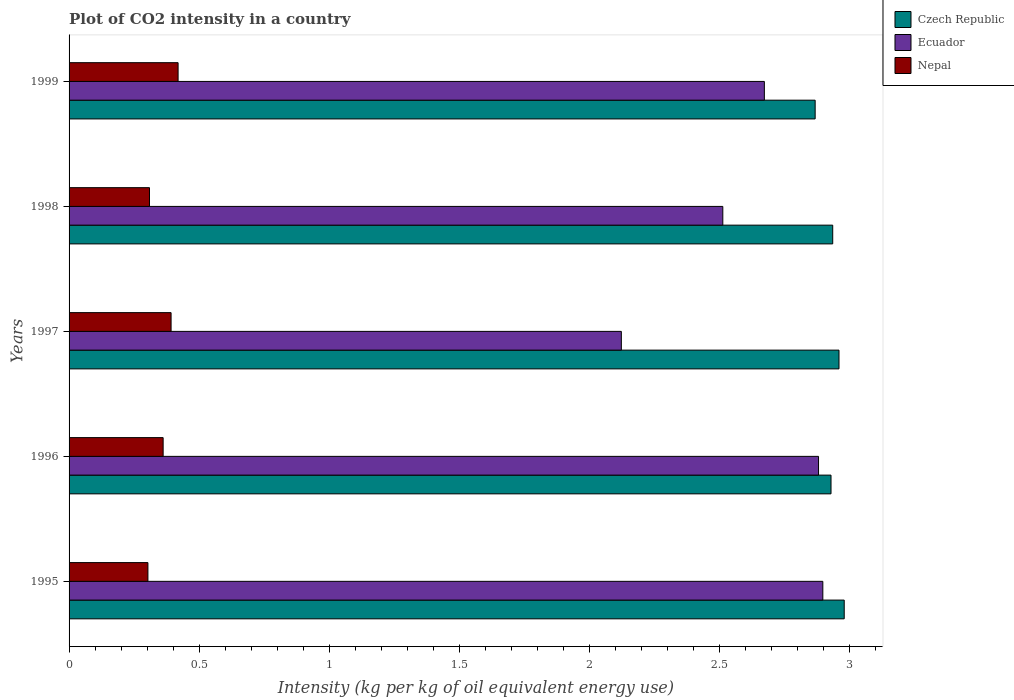Are the number of bars per tick equal to the number of legend labels?
Make the answer very short. Yes. Are the number of bars on each tick of the Y-axis equal?
Your response must be concise. Yes. How many bars are there on the 2nd tick from the top?
Give a very brief answer. 3. How many bars are there on the 2nd tick from the bottom?
Your answer should be compact. 3. In how many cases, is the number of bars for a given year not equal to the number of legend labels?
Ensure brevity in your answer.  0. What is the CO2 intensity in in Nepal in 1997?
Keep it short and to the point. 0.39. Across all years, what is the maximum CO2 intensity in in Czech Republic?
Ensure brevity in your answer.  2.98. Across all years, what is the minimum CO2 intensity in in Czech Republic?
Ensure brevity in your answer.  2.87. In which year was the CO2 intensity in in Ecuador minimum?
Keep it short and to the point. 1997. What is the total CO2 intensity in in Czech Republic in the graph?
Give a very brief answer. 14.68. What is the difference between the CO2 intensity in in Ecuador in 1995 and that in 1996?
Give a very brief answer. 0.02. What is the difference between the CO2 intensity in in Czech Republic in 1996 and the CO2 intensity in in Ecuador in 1995?
Ensure brevity in your answer.  0.03. What is the average CO2 intensity in in Nepal per year?
Offer a terse response. 0.36. In the year 1996, what is the difference between the CO2 intensity in in Czech Republic and CO2 intensity in in Nepal?
Keep it short and to the point. 2.57. In how many years, is the CO2 intensity in in Czech Republic greater than 1.2 kg?
Provide a short and direct response. 5. What is the ratio of the CO2 intensity in in Ecuador in 1997 to that in 1998?
Ensure brevity in your answer.  0.84. What is the difference between the highest and the second highest CO2 intensity in in Nepal?
Your answer should be compact. 0.03. What is the difference between the highest and the lowest CO2 intensity in in Czech Republic?
Your response must be concise. 0.11. In how many years, is the CO2 intensity in in Ecuador greater than the average CO2 intensity in in Ecuador taken over all years?
Make the answer very short. 3. Is the sum of the CO2 intensity in in Czech Republic in 1996 and 1998 greater than the maximum CO2 intensity in in Nepal across all years?
Provide a succinct answer. Yes. What does the 1st bar from the top in 1996 represents?
Give a very brief answer. Nepal. What does the 1st bar from the bottom in 1997 represents?
Your answer should be very brief. Czech Republic. Are all the bars in the graph horizontal?
Provide a short and direct response. Yes. What is the difference between two consecutive major ticks on the X-axis?
Keep it short and to the point. 0.5. Are the values on the major ticks of X-axis written in scientific E-notation?
Keep it short and to the point. No. Does the graph contain grids?
Keep it short and to the point. No. How many legend labels are there?
Your answer should be very brief. 3. What is the title of the graph?
Offer a very short reply. Plot of CO2 intensity in a country. What is the label or title of the X-axis?
Your answer should be very brief. Intensity (kg per kg of oil equivalent energy use). What is the label or title of the Y-axis?
Keep it short and to the point. Years. What is the Intensity (kg per kg of oil equivalent energy use) in Czech Republic in 1995?
Offer a very short reply. 2.98. What is the Intensity (kg per kg of oil equivalent energy use) in Ecuador in 1995?
Give a very brief answer. 2.9. What is the Intensity (kg per kg of oil equivalent energy use) in Nepal in 1995?
Your response must be concise. 0.3. What is the Intensity (kg per kg of oil equivalent energy use) of Czech Republic in 1996?
Make the answer very short. 2.93. What is the Intensity (kg per kg of oil equivalent energy use) of Ecuador in 1996?
Ensure brevity in your answer.  2.88. What is the Intensity (kg per kg of oil equivalent energy use) in Nepal in 1996?
Keep it short and to the point. 0.36. What is the Intensity (kg per kg of oil equivalent energy use) in Czech Republic in 1997?
Give a very brief answer. 2.96. What is the Intensity (kg per kg of oil equivalent energy use) of Ecuador in 1997?
Provide a short and direct response. 2.12. What is the Intensity (kg per kg of oil equivalent energy use) of Nepal in 1997?
Make the answer very short. 0.39. What is the Intensity (kg per kg of oil equivalent energy use) in Czech Republic in 1998?
Provide a short and direct response. 2.94. What is the Intensity (kg per kg of oil equivalent energy use) in Ecuador in 1998?
Offer a very short reply. 2.51. What is the Intensity (kg per kg of oil equivalent energy use) of Nepal in 1998?
Ensure brevity in your answer.  0.31. What is the Intensity (kg per kg of oil equivalent energy use) of Czech Republic in 1999?
Keep it short and to the point. 2.87. What is the Intensity (kg per kg of oil equivalent energy use) of Ecuador in 1999?
Your answer should be very brief. 2.67. What is the Intensity (kg per kg of oil equivalent energy use) in Nepal in 1999?
Give a very brief answer. 0.42. Across all years, what is the maximum Intensity (kg per kg of oil equivalent energy use) in Czech Republic?
Make the answer very short. 2.98. Across all years, what is the maximum Intensity (kg per kg of oil equivalent energy use) of Ecuador?
Give a very brief answer. 2.9. Across all years, what is the maximum Intensity (kg per kg of oil equivalent energy use) in Nepal?
Your answer should be very brief. 0.42. Across all years, what is the minimum Intensity (kg per kg of oil equivalent energy use) in Czech Republic?
Keep it short and to the point. 2.87. Across all years, what is the minimum Intensity (kg per kg of oil equivalent energy use) in Ecuador?
Provide a succinct answer. 2.12. Across all years, what is the minimum Intensity (kg per kg of oil equivalent energy use) of Nepal?
Your response must be concise. 0.3. What is the total Intensity (kg per kg of oil equivalent energy use) in Czech Republic in the graph?
Your answer should be compact. 14.68. What is the total Intensity (kg per kg of oil equivalent energy use) of Ecuador in the graph?
Give a very brief answer. 13.09. What is the total Intensity (kg per kg of oil equivalent energy use) of Nepal in the graph?
Offer a terse response. 1.79. What is the difference between the Intensity (kg per kg of oil equivalent energy use) of Czech Republic in 1995 and that in 1996?
Your answer should be very brief. 0.05. What is the difference between the Intensity (kg per kg of oil equivalent energy use) in Ecuador in 1995 and that in 1996?
Make the answer very short. 0.02. What is the difference between the Intensity (kg per kg of oil equivalent energy use) of Nepal in 1995 and that in 1996?
Your answer should be very brief. -0.06. What is the difference between the Intensity (kg per kg of oil equivalent energy use) of Czech Republic in 1995 and that in 1997?
Make the answer very short. 0.02. What is the difference between the Intensity (kg per kg of oil equivalent energy use) of Ecuador in 1995 and that in 1997?
Ensure brevity in your answer.  0.77. What is the difference between the Intensity (kg per kg of oil equivalent energy use) of Nepal in 1995 and that in 1997?
Your answer should be compact. -0.09. What is the difference between the Intensity (kg per kg of oil equivalent energy use) of Czech Republic in 1995 and that in 1998?
Your answer should be very brief. 0.04. What is the difference between the Intensity (kg per kg of oil equivalent energy use) of Ecuador in 1995 and that in 1998?
Your answer should be compact. 0.38. What is the difference between the Intensity (kg per kg of oil equivalent energy use) of Nepal in 1995 and that in 1998?
Your answer should be very brief. -0.01. What is the difference between the Intensity (kg per kg of oil equivalent energy use) of Czech Republic in 1995 and that in 1999?
Your response must be concise. 0.11. What is the difference between the Intensity (kg per kg of oil equivalent energy use) in Ecuador in 1995 and that in 1999?
Provide a short and direct response. 0.22. What is the difference between the Intensity (kg per kg of oil equivalent energy use) in Nepal in 1995 and that in 1999?
Provide a short and direct response. -0.12. What is the difference between the Intensity (kg per kg of oil equivalent energy use) of Czech Republic in 1996 and that in 1997?
Give a very brief answer. -0.03. What is the difference between the Intensity (kg per kg of oil equivalent energy use) of Ecuador in 1996 and that in 1997?
Provide a short and direct response. 0.76. What is the difference between the Intensity (kg per kg of oil equivalent energy use) of Nepal in 1996 and that in 1997?
Give a very brief answer. -0.03. What is the difference between the Intensity (kg per kg of oil equivalent energy use) of Czech Republic in 1996 and that in 1998?
Ensure brevity in your answer.  -0.01. What is the difference between the Intensity (kg per kg of oil equivalent energy use) in Ecuador in 1996 and that in 1998?
Your response must be concise. 0.37. What is the difference between the Intensity (kg per kg of oil equivalent energy use) of Nepal in 1996 and that in 1998?
Give a very brief answer. 0.05. What is the difference between the Intensity (kg per kg of oil equivalent energy use) of Czech Republic in 1996 and that in 1999?
Your answer should be compact. 0.06. What is the difference between the Intensity (kg per kg of oil equivalent energy use) in Ecuador in 1996 and that in 1999?
Give a very brief answer. 0.21. What is the difference between the Intensity (kg per kg of oil equivalent energy use) of Nepal in 1996 and that in 1999?
Provide a short and direct response. -0.06. What is the difference between the Intensity (kg per kg of oil equivalent energy use) in Czech Republic in 1997 and that in 1998?
Offer a very short reply. 0.02. What is the difference between the Intensity (kg per kg of oil equivalent energy use) of Ecuador in 1997 and that in 1998?
Your answer should be very brief. -0.39. What is the difference between the Intensity (kg per kg of oil equivalent energy use) of Nepal in 1997 and that in 1998?
Offer a very short reply. 0.08. What is the difference between the Intensity (kg per kg of oil equivalent energy use) in Czech Republic in 1997 and that in 1999?
Give a very brief answer. 0.09. What is the difference between the Intensity (kg per kg of oil equivalent energy use) of Ecuador in 1997 and that in 1999?
Provide a short and direct response. -0.55. What is the difference between the Intensity (kg per kg of oil equivalent energy use) of Nepal in 1997 and that in 1999?
Your answer should be compact. -0.03. What is the difference between the Intensity (kg per kg of oil equivalent energy use) of Czech Republic in 1998 and that in 1999?
Make the answer very short. 0.07. What is the difference between the Intensity (kg per kg of oil equivalent energy use) of Ecuador in 1998 and that in 1999?
Ensure brevity in your answer.  -0.16. What is the difference between the Intensity (kg per kg of oil equivalent energy use) in Nepal in 1998 and that in 1999?
Provide a short and direct response. -0.11. What is the difference between the Intensity (kg per kg of oil equivalent energy use) of Czech Republic in 1995 and the Intensity (kg per kg of oil equivalent energy use) of Ecuador in 1996?
Offer a very short reply. 0.1. What is the difference between the Intensity (kg per kg of oil equivalent energy use) in Czech Republic in 1995 and the Intensity (kg per kg of oil equivalent energy use) in Nepal in 1996?
Provide a succinct answer. 2.62. What is the difference between the Intensity (kg per kg of oil equivalent energy use) of Ecuador in 1995 and the Intensity (kg per kg of oil equivalent energy use) of Nepal in 1996?
Offer a very short reply. 2.54. What is the difference between the Intensity (kg per kg of oil equivalent energy use) of Czech Republic in 1995 and the Intensity (kg per kg of oil equivalent energy use) of Ecuador in 1997?
Provide a short and direct response. 0.86. What is the difference between the Intensity (kg per kg of oil equivalent energy use) of Czech Republic in 1995 and the Intensity (kg per kg of oil equivalent energy use) of Nepal in 1997?
Your answer should be compact. 2.59. What is the difference between the Intensity (kg per kg of oil equivalent energy use) in Ecuador in 1995 and the Intensity (kg per kg of oil equivalent energy use) in Nepal in 1997?
Provide a short and direct response. 2.51. What is the difference between the Intensity (kg per kg of oil equivalent energy use) of Czech Republic in 1995 and the Intensity (kg per kg of oil equivalent energy use) of Ecuador in 1998?
Give a very brief answer. 0.47. What is the difference between the Intensity (kg per kg of oil equivalent energy use) of Czech Republic in 1995 and the Intensity (kg per kg of oil equivalent energy use) of Nepal in 1998?
Offer a very short reply. 2.67. What is the difference between the Intensity (kg per kg of oil equivalent energy use) of Ecuador in 1995 and the Intensity (kg per kg of oil equivalent energy use) of Nepal in 1998?
Provide a short and direct response. 2.59. What is the difference between the Intensity (kg per kg of oil equivalent energy use) of Czech Republic in 1995 and the Intensity (kg per kg of oil equivalent energy use) of Ecuador in 1999?
Keep it short and to the point. 0.31. What is the difference between the Intensity (kg per kg of oil equivalent energy use) of Czech Republic in 1995 and the Intensity (kg per kg of oil equivalent energy use) of Nepal in 1999?
Your answer should be compact. 2.56. What is the difference between the Intensity (kg per kg of oil equivalent energy use) of Ecuador in 1995 and the Intensity (kg per kg of oil equivalent energy use) of Nepal in 1999?
Give a very brief answer. 2.48. What is the difference between the Intensity (kg per kg of oil equivalent energy use) of Czech Republic in 1996 and the Intensity (kg per kg of oil equivalent energy use) of Ecuador in 1997?
Provide a short and direct response. 0.81. What is the difference between the Intensity (kg per kg of oil equivalent energy use) in Czech Republic in 1996 and the Intensity (kg per kg of oil equivalent energy use) in Nepal in 1997?
Make the answer very short. 2.54. What is the difference between the Intensity (kg per kg of oil equivalent energy use) of Ecuador in 1996 and the Intensity (kg per kg of oil equivalent energy use) of Nepal in 1997?
Your answer should be very brief. 2.49. What is the difference between the Intensity (kg per kg of oil equivalent energy use) of Czech Republic in 1996 and the Intensity (kg per kg of oil equivalent energy use) of Ecuador in 1998?
Make the answer very short. 0.42. What is the difference between the Intensity (kg per kg of oil equivalent energy use) in Czech Republic in 1996 and the Intensity (kg per kg of oil equivalent energy use) in Nepal in 1998?
Offer a terse response. 2.62. What is the difference between the Intensity (kg per kg of oil equivalent energy use) in Ecuador in 1996 and the Intensity (kg per kg of oil equivalent energy use) in Nepal in 1998?
Your response must be concise. 2.57. What is the difference between the Intensity (kg per kg of oil equivalent energy use) of Czech Republic in 1996 and the Intensity (kg per kg of oil equivalent energy use) of Ecuador in 1999?
Your answer should be very brief. 0.26. What is the difference between the Intensity (kg per kg of oil equivalent energy use) of Czech Republic in 1996 and the Intensity (kg per kg of oil equivalent energy use) of Nepal in 1999?
Ensure brevity in your answer.  2.51. What is the difference between the Intensity (kg per kg of oil equivalent energy use) of Ecuador in 1996 and the Intensity (kg per kg of oil equivalent energy use) of Nepal in 1999?
Your answer should be very brief. 2.46. What is the difference between the Intensity (kg per kg of oil equivalent energy use) of Czech Republic in 1997 and the Intensity (kg per kg of oil equivalent energy use) of Ecuador in 1998?
Provide a short and direct response. 0.45. What is the difference between the Intensity (kg per kg of oil equivalent energy use) of Czech Republic in 1997 and the Intensity (kg per kg of oil equivalent energy use) of Nepal in 1998?
Ensure brevity in your answer.  2.65. What is the difference between the Intensity (kg per kg of oil equivalent energy use) of Ecuador in 1997 and the Intensity (kg per kg of oil equivalent energy use) of Nepal in 1998?
Offer a very short reply. 1.81. What is the difference between the Intensity (kg per kg of oil equivalent energy use) of Czech Republic in 1997 and the Intensity (kg per kg of oil equivalent energy use) of Ecuador in 1999?
Keep it short and to the point. 0.29. What is the difference between the Intensity (kg per kg of oil equivalent energy use) in Czech Republic in 1997 and the Intensity (kg per kg of oil equivalent energy use) in Nepal in 1999?
Keep it short and to the point. 2.54. What is the difference between the Intensity (kg per kg of oil equivalent energy use) in Ecuador in 1997 and the Intensity (kg per kg of oil equivalent energy use) in Nepal in 1999?
Offer a terse response. 1.7. What is the difference between the Intensity (kg per kg of oil equivalent energy use) in Czech Republic in 1998 and the Intensity (kg per kg of oil equivalent energy use) in Ecuador in 1999?
Offer a terse response. 0.26. What is the difference between the Intensity (kg per kg of oil equivalent energy use) in Czech Republic in 1998 and the Intensity (kg per kg of oil equivalent energy use) in Nepal in 1999?
Provide a succinct answer. 2.52. What is the difference between the Intensity (kg per kg of oil equivalent energy use) of Ecuador in 1998 and the Intensity (kg per kg of oil equivalent energy use) of Nepal in 1999?
Offer a very short reply. 2.09. What is the average Intensity (kg per kg of oil equivalent energy use) in Czech Republic per year?
Your answer should be very brief. 2.94. What is the average Intensity (kg per kg of oil equivalent energy use) in Ecuador per year?
Make the answer very short. 2.62. What is the average Intensity (kg per kg of oil equivalent energy use) of Nepal per year?
Your answer should be compact. 0.36. In the year 1995, what is the difference between the Intensity (kg per kg of oil equivalent energy use) in Czech Republic and Intensity (kg per kg of oil equivalent energy use) in Ecuador?
Give a very brief answer. 0.08. In the year 1995, what is the difference between the Intensity (kg per kg of oil equivalent energy use) of Czech Republic and Intensity (kg per kg of oil equivalent energy use) of Nepal?
Offer a terse response. 2.68. In the year 1995, what is the difference between the Intensity (kg per kg of oil equivalent energy use) of Ecuador and Intensity (kg per kg of oil equivalent energy use) of Nepal?
Your answer should be very brief. 2.6. In the year 1996, what is the difference between the Intensity (kg per kg of oil equivalent energy use) in Czech Republic and Intensity (kg per kg of oil equivalent energy use) in Ecuador?
Your response must be concise. 0.05. In the year 1996, what is the difference between the Intensity (kg per kg of oil equivalent energy use) of Czech Republic and Intensity (kg per kg of oil equivalent energy use) of Nepal?
Your answer should be compact. 2.57. In the year 1996, what is the difference between the Intensity (kg per kg of oil equivalent energy use) in Ecuador and Intensity (kg per kg of oil equivalent energy use) in Nepal?
Keep it short and to the point. 2.52. In the year 1997, what is the difference between the Intensity (kg per kg of oil equivalent energy use) of Czech Republic and Intensity (kg per kg of oil equivalent energy use) of Ecuador?
Offer a very short reply. 0.84. In the year 1997, what is the difference between the Intensity (kg per kg of oil equivalent energy use) of Czech Republic and Intensity (kg per kg of oil equivalent energy use) of Nepal?
Your response must be concise. 2.57. In the year 1997, what is the difference between the Intensity (kg per kg of oil equivalent energy use) in Ecuador and Intensity (kg per kg of oil equivalent energy use) in Nepal?
Provide a short and direct response. 1.73. In the year 1998, what is the difference between the Intensity (kg per kg of oil equivalent energy use) of Czech Republic and Intensity (kg per kg of oil equivalent energy use) of Ecuador?
Offer a very short reply. 0.42. In the year 1998, what is the difference between the Intensity (kg per kg of oil equivalent energy use) of Czech Republic and Intensity (kg per kg of oil equivalent energy use) of Nepal?
Your answer should be compact. 2.63. In the year 1998, what is the difference between the Intensity (kg per kg of oil equivalent energy use) in Ecuador and Intensity (kg per kg of oil equivalent energy use) in Nepal?
Provide a succinct answer. 2.2. In the year 1999, what is the difference between the Intensity (kg per kg of oil equivalent energy use) of Czech Republic and Intensity (kg per kg of oil equivalent energy use) of Ecuador?
Your answer should be very brief. 0.2. In the year 1999, what is the difference between the Intensity (kg per kg of oil equivalent energy use) of Czech Republic and Intensity (kg per kg of oil equivalent energy use) of Nepal?
Offer a very short reply. 2.45. In the year 1999, what is the difference between the Intensity (kg per kg of oil equivalent energy use) of Ecuador and Intensity (kg per kg of oil equivalent energy use) of Nepal?
Offer a terse response. 2.25. What is the ratio of the Intensity (kg per kg of oil equivalent energy use) of Czech Republic in 1995 to that in 1996?
Give a very brief answer. 1.02. What is the ratio of the Intensity (kg per kg of oil equivalent energy use) in Nepal in 1995 to that in 1996?
Your answer should be compact. 0.84. What is the ratio of the Intensity (kg per kg of oil equivalent energy use) of Czech Republic in 1995 to that in 1997?
Make the answer very short. 1.01. What is the ratio of the Intensity (kg per kg of oil equivalent energy use) of Ecuador in 1995 to that in 1997?
Your answer should be compact. 1.36. What is the ratio of the Intensity (kg per kg of oil equivalent energy use) in Nepal in 1995 to that in 1997?
Offer a terse response. 0.77. What is the ratio of the Intensity (kg per kg of oil equivalent energy use) of Czech Republic in 1995 to that in 1998?
Ensure brevity in your answer.  1.02. What is the ratio of the Intensity (kg per kg of oil equivalent energy use) of Ecuador in 1995 to that in 1998?
Ensure brevity in your answer.  1.15. What is the ratio of the Intensity (kg per kg of oil equivalent energy use) in Nepal in 1995 to that in 1998?
Ensure brevity in your answer.  0.98. What is the ratio of the Intensity (kg per kg of oil equivalent energy use) of Czech Republic in 1995 to that in 1999?
Make the answer very short. 1.04. What is the ratio of the Intensity (kg per kg of oil equivalent energy use) in Ecuador in 1995 to that in 1999?
Your answer should be compact. 1.08. What is the ratio of the Intensity (kg per kg of oil equivalent energy use) of Nepal in 1995 to that in 1999?
Provide a succinct answer. 0.72. What is the ratio of the Intensity (kg per kg of oil equivalent energy use) in Ecuador in 1996 to that in 1997?
Keep it short and to the point. 1.36. What is the ratio of the Intensity (kg per kg of oil equivalent energy use) of Nepal in 1996 to that in 1997?
Provide a succinct answer. 0.92. What is the ratio of the Intensity (kg per kg of oil equivalent energy use) in Ecuador in 1996 to that in 1998?
Offer a very short reply. 1.15. What is the ratio of the Intensity (kg per kg of oil equivalent energy use) in Nepal in 1996 to that in 1998?
Offer a very short reply. 1.17. What is the ratio of the Intensity (kg per kg of oil equivalent energy use) in Czech Republic in 1996 to that in 1999?
Provide a succinct answer. 1.02. What is the ratio of the Intensity (kg per kg of oil equivalent energy use) of Ecuador in 1996 to that in 1999?
Your answer should be compact. 1.08. What is the ratio of the Intensity (kg per kg of oil equivalent energy use) of Nepal in 1996 to that in 1999?
Provide a succinct answer. 0.86. What is the ratio of the Intensity (kg per kg of oil equivalent energy use) of Czech Republic in 1997 to that in 1998?
Give a very brief answer. 1.01. What is the ratio of the Intensity (kg per kg of oil equivalent energy use) in Ecuador in 1997 to that in 1998?
Your response must be concise. 0.84. What is the ratio of the Intensity (kg per kg of oil equivalent energy use) of Nepal in 1997 to that in 1998?
Your answer should be compact. 1.27. What is the ratio of the Intensity (kg per kg of oil equivalent energy use) of Czech Republic in 1997 to that in 1999?
Your answer should be very brief. 1.03. What is the ratio of the Intensity (kg per kg of oil equivalent energy use) of Ecuador in 1997 to that in 1999?
Keep it short and to the point. 0.79. What is the ratio of the Intensity (kg per kg of oil equivalent energy use) in Nepal in 1997 to that in 1999?
Give a very brief answer. 0.94. What is the ratio of the Intensity (kg per kg of oil equivalent energy use) of Czech Republic in 1998 to that in 1999?
Offer a very short reply. 1.02. What is the ratio of the Intensity (kg per kg of oil equivalent energy use) in Ecuador in 1998 to that in 1999?
Provide a succinct answer. 0.94. What is the ratio of the Intensity (kg per kg of oil equivalent energy use) in Nepal in 1998 to that in 1999?
Provide a short and direct response. 0.74. What is the difference between the highest and the second highest Intensity (kg per kg of oil equivalent energy use) of Czech Republic?
Provide a short and direct response. 0.02. What is the difference between the highest and the second highest Intensity (kg per kg of oil equivalent energy use) in Ecuador?
Offer a terse response. 0.02. What is the difference between the highest and the second highest Intensity (kg per kg of oil equivalent energy use) of Nepal?
Offer a terse response. 0.03. What is the difference between the highest and the lowest Intensity (kg per kg of oil equivalent energy use) of Czech Republic?
Your answer should be compact. 0.11. What is the difference between the highest and the lowest Intensity (kg per kg of oil equivalent energy use) of Ecuador?
Ensure brevity in your answer.  0.77. What is the difference between the highest and the lowest Intensity (kg per kg of oil equivalent energy use) of Nepal?
Provide a succinct answer. 0.12. 